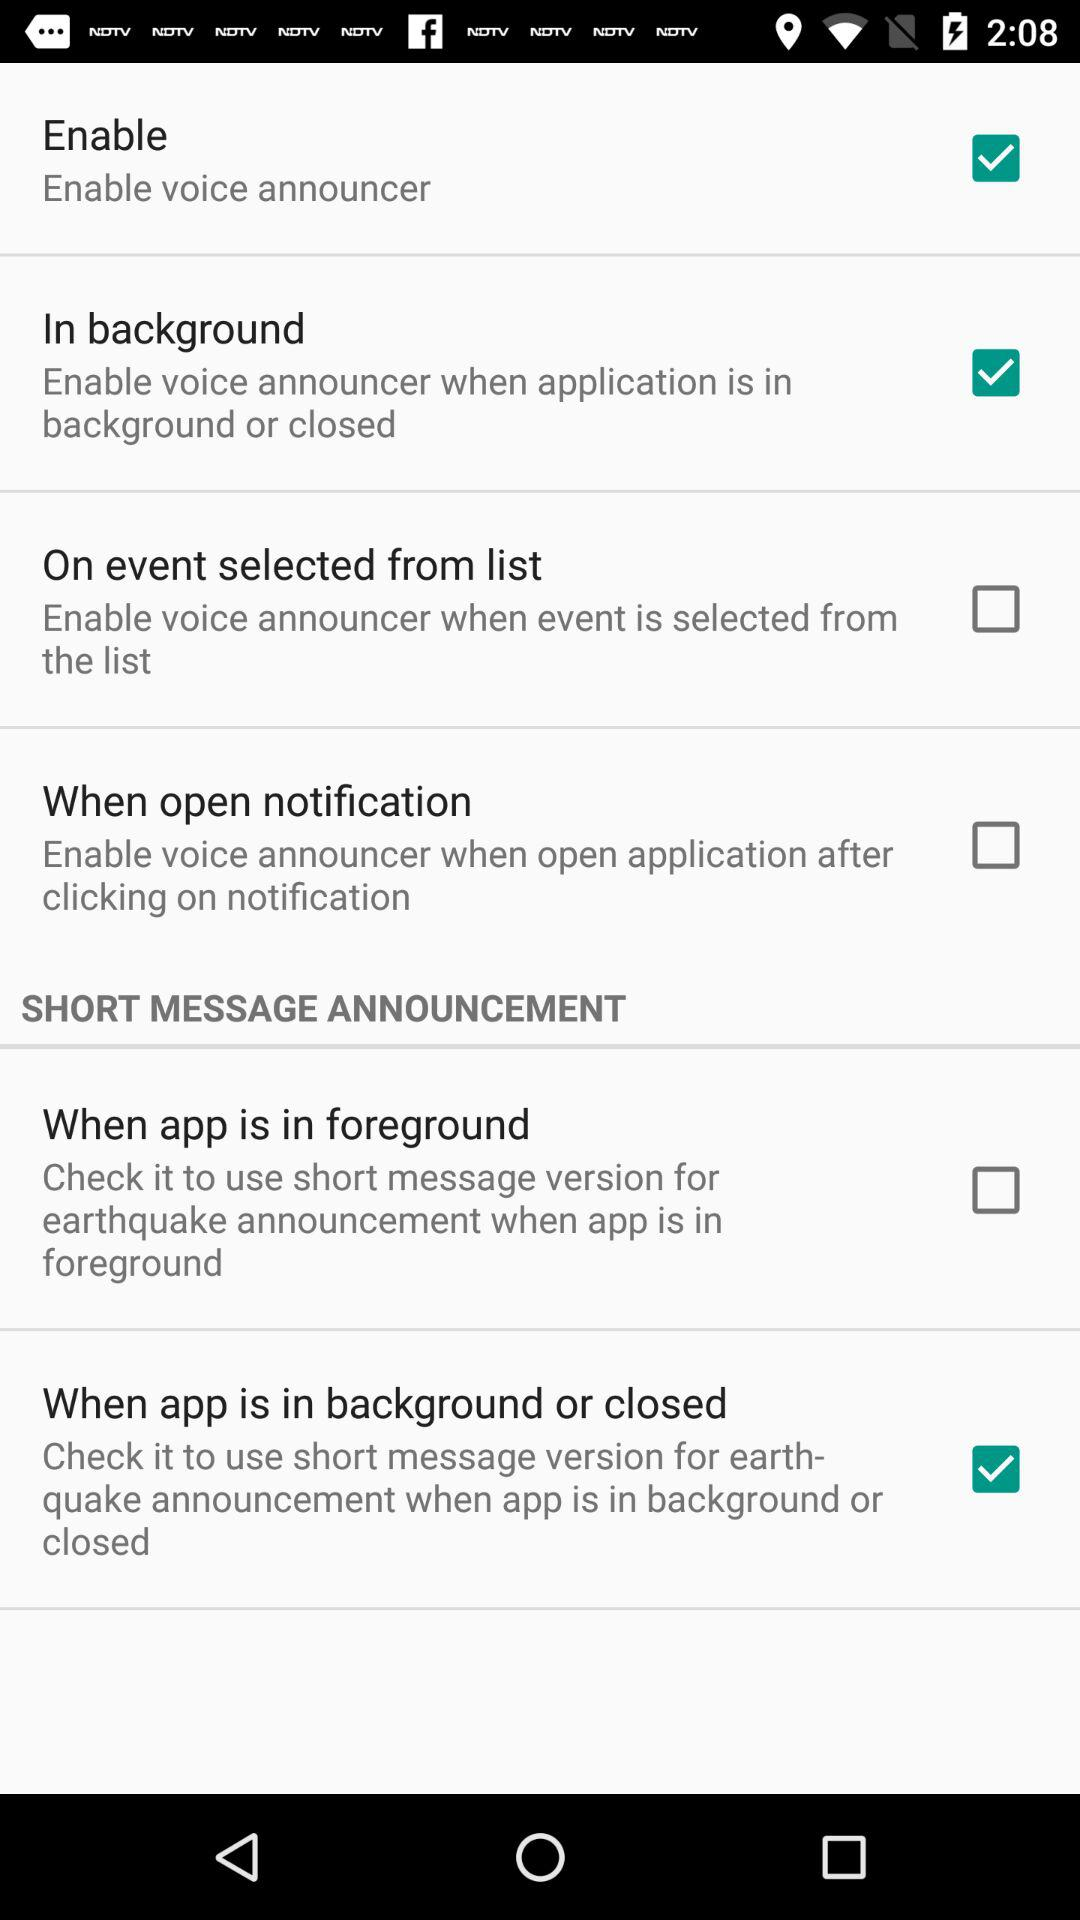Which option is checked? The checked options are "Enable", "In background" and "When app is in background or closed". 